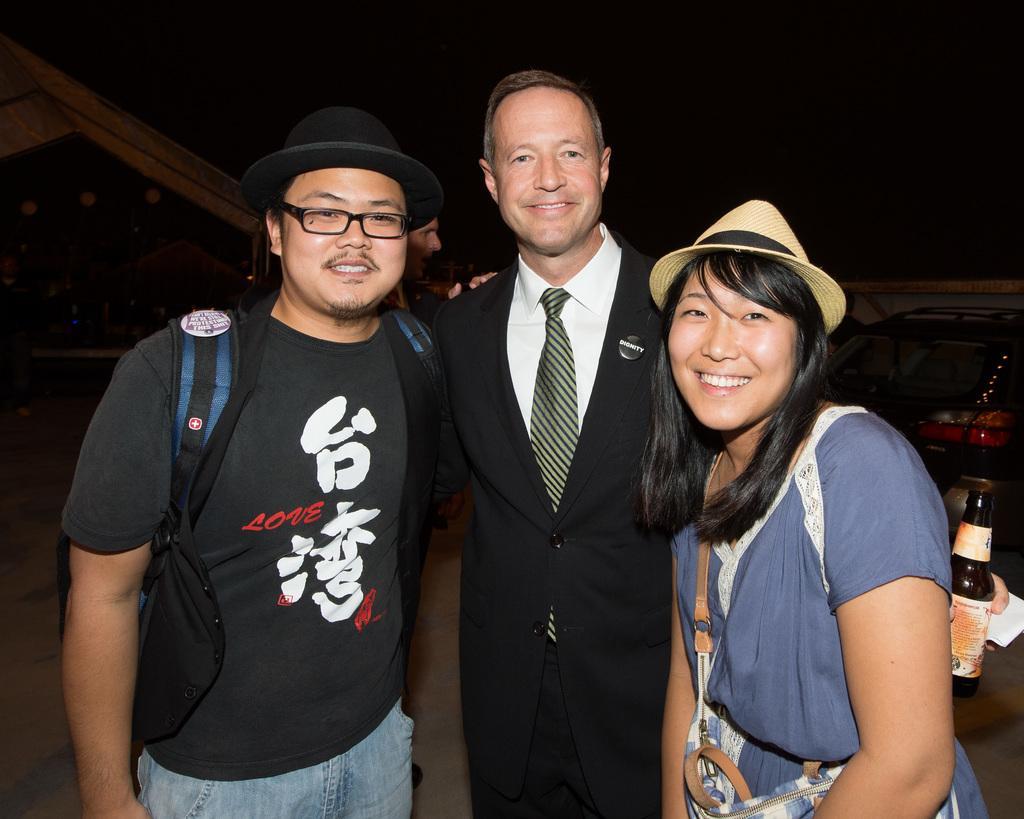Please provide a concise description of this image. In the center of the image we can see three people standing and smiling. The man standing in the center is holding a bottle in his hand. In the background there is a car, tent and sky. 